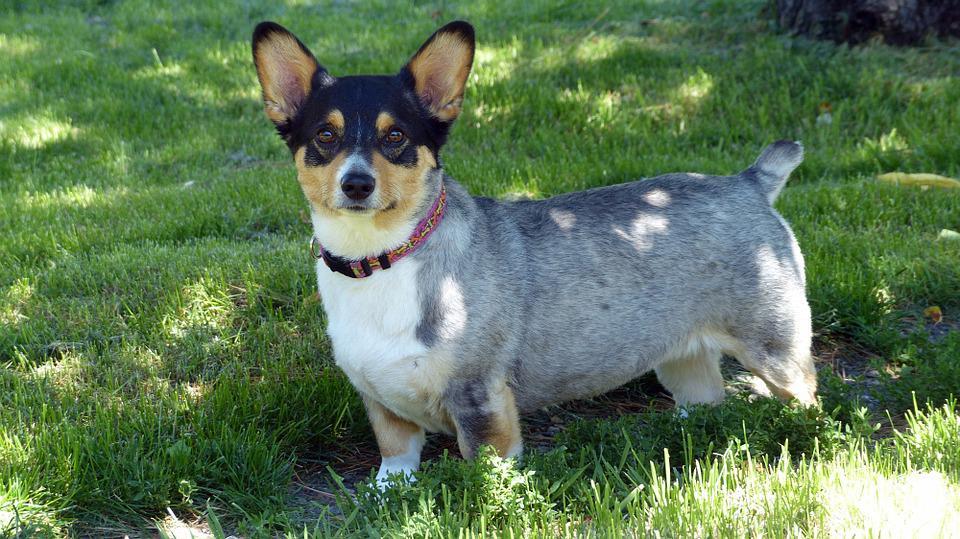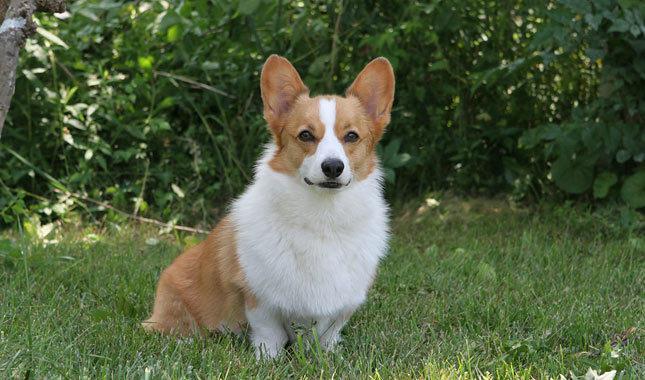The first image is the image on the left, the second image is the image on the right. Evaluate the accuracy of this statement regarding the images: "The dogs in the images are standing with bodies turned in opposite directions.". Is it true? Answer yes or no. No. 